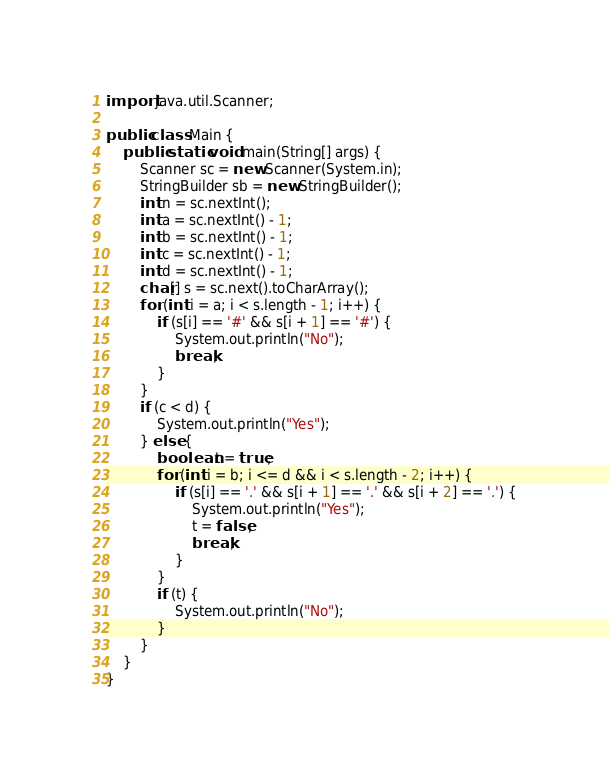Convert code to text. <code><loc_0><loc_0><loc_500><loc_500><_Java_>import java.util.Scanner;

public class Main {
	public static void main(String[] args) {
		Scanner sc = new Scanner(System.in);
		StringBuilder sb = new StringBuilder();
		int n = sc.nextInt();
		int a = sc.nextInt() - 1;
		int b = sc.nextInt() - 1;
		int c = sc.nextInt() - 1;
		int d = sc.nextInt() - 1;
		char[] s = sc.next().toCharArray();
		for (int i = a; i < s.length - 1; i++) {
			if (s[i] == '#' && s[i + 1] == '#') {
				System.out.println("No");
				break;
			}
		}
		if (c < d) {
			System.out.println("Yes");
		} else {
			boolean t = true;
			for (int i = b; i <= d && i < s.length - 2; i++) {
				if (s[i] == '.' && s[i + 1] == '.' && s[i + 2] == '.') {
					System.out.println("Yes");
					t = false;
					break;
				}
			}
			if (t) {
				System.out.println("No");
			}
		}
	}
}</code> 